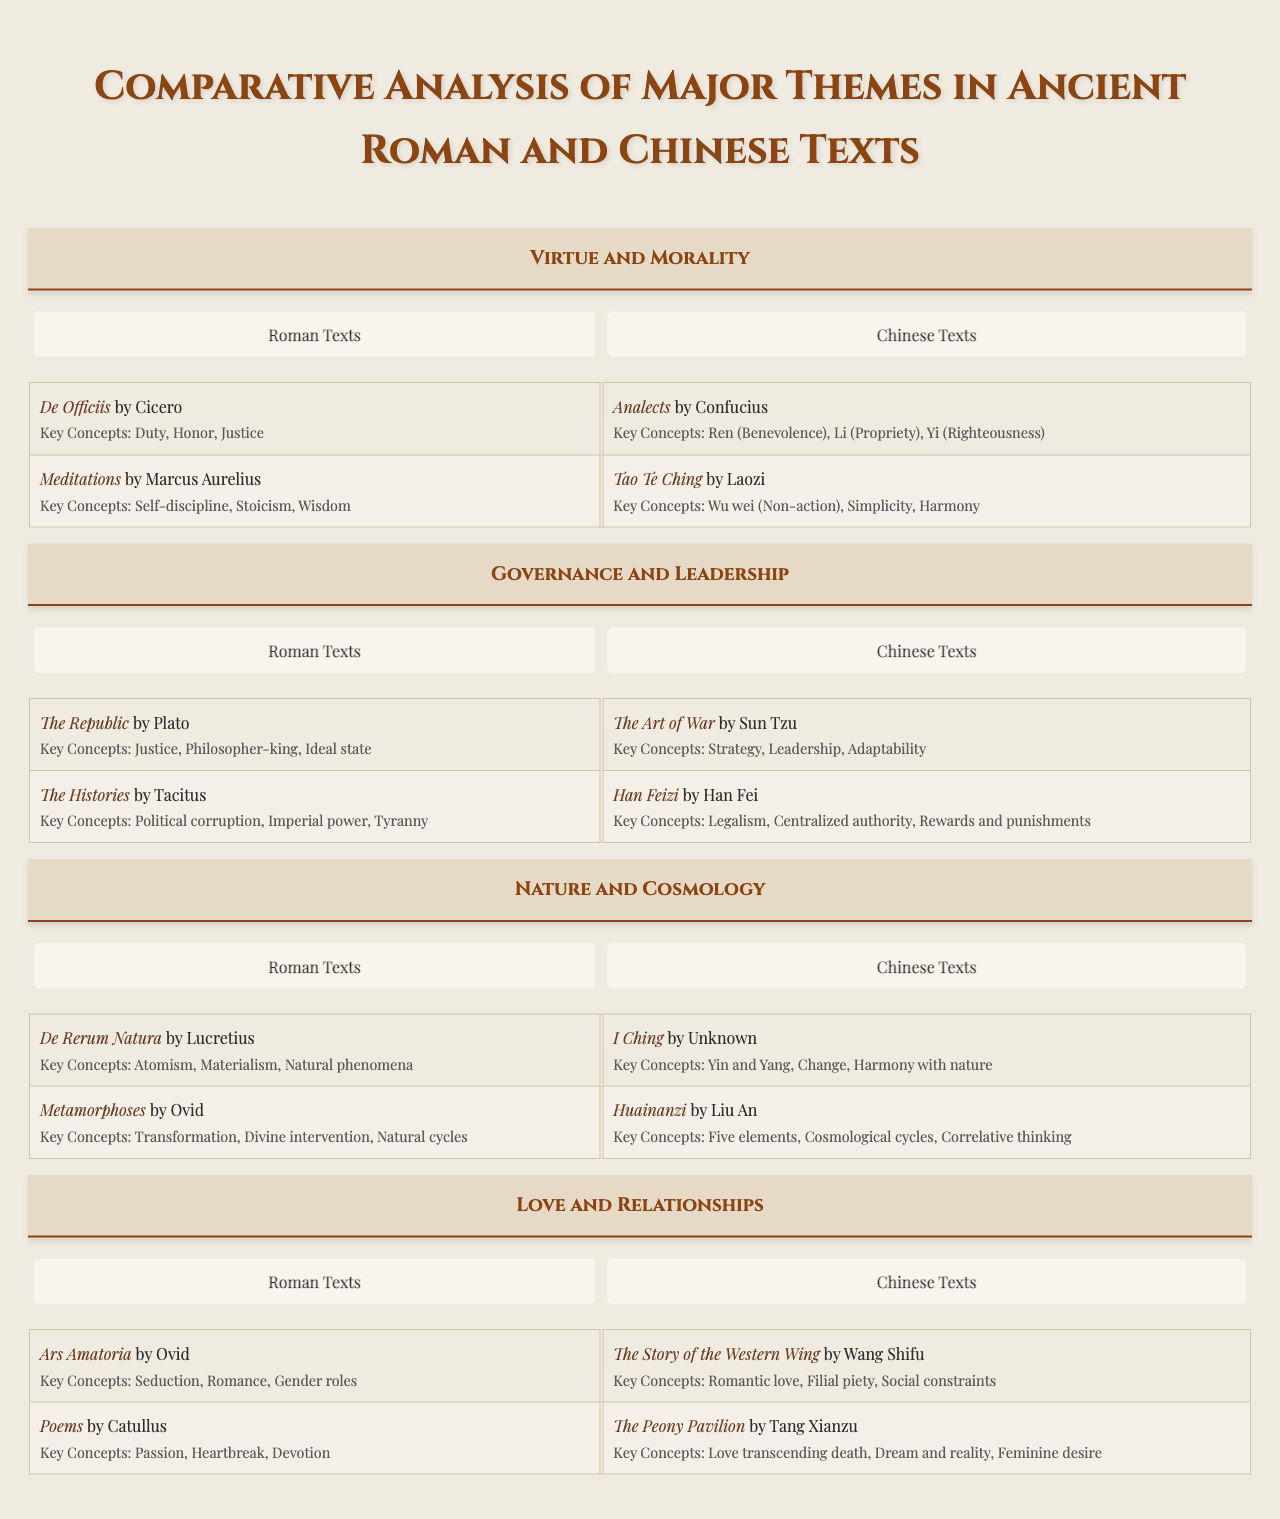What are the key concepts in "De Officiis" by Cicero? The table lists "De Officiis" under the theme "Virtue and Morality," with key concepts including "Duty," "Honor," and "Justice."
Answer: Duty, Honor, Justice Which theme includes the work "The Art of War"? "The Art of War" is listed under the theme "Governance and Leadership."
Answer: Governance and Leadership How many Roman texts are mentioned under the theme "Nature and Cosmology"? Under "Nature and Cosmology," there are two Roman texts listed: "De Rerum Natura" by Lucretius and "Metamorphoses" by Ovid.
Answer: 2 Are there any Chinese texts that discuss "Love and Relationships"? Yes, the theme "Love and Relationships" includes two Chinese texts: "The Story of the Western Wing" by Wang Shifu and "The Peony Pavilion" by Tang Xianzu.
Answer: Yes Which author is associated with the key concepts "Strategy," "Leadership," and "Adaptability"? These key concepts are associated with "The Art of War" by Sun Tzu, listed under the theme "Governance and Leadership."
Answer: Sun Tzu What is the difference in the number of texts listed between the themes "Virtue and Morality" and "Love and Relationships"? Both themes contain two texts each, resulting in a difference of zero texts.
Answer: 0 What key concept emphasizes "Wu wei" and in which text is it found? The key concept of "Wu wei (Non-action)" is found in "Tao Te Ching" by Laozi under the theme "Virtue and Morality."
Answer: Tao Te Ching In which theme is the concept of "Yin and Yang" found, and what is its significance? "Yin and Yang" is found under the theme "Nature and Cosmology" in the work "I Ching," signifying the balance of opposite forces.
Answer: Nature and Cosmology Which theme features both Roman and Chinese texts that discuss ideas of power? The theme "Governance and Leadership" features both Roman texts (like "The Histories" by Tacitus) and Chinese texts (like "Han Feizi").
Answer: Governance and Leadership Identify two key concepts from the work "Analects" and explain their relevance. The key concepts from the "Analects" by Confucius are "Ren (Benevolence)" and "Li (Propriety)," which emphasize ethical behavior and societal norms in relationships.
Answer: Ren, Li Which is the only Roman text listed under "Love and Relationships" that focuses on aspects of seduction? The Roman text that focuses on seduction is "Ars Amatoria" by Ovid.
Answer: Ars Amatoria 